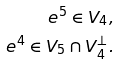Convert formula to latex. <formula><loc_0><loc_0><loc_500><loc_500>e ^ { 5 } \in V _ { 4 } , \\ e ^ { 4 } \in V _ { 5 } \cap V _ { 4 } ^ { \perp } .</formula> 